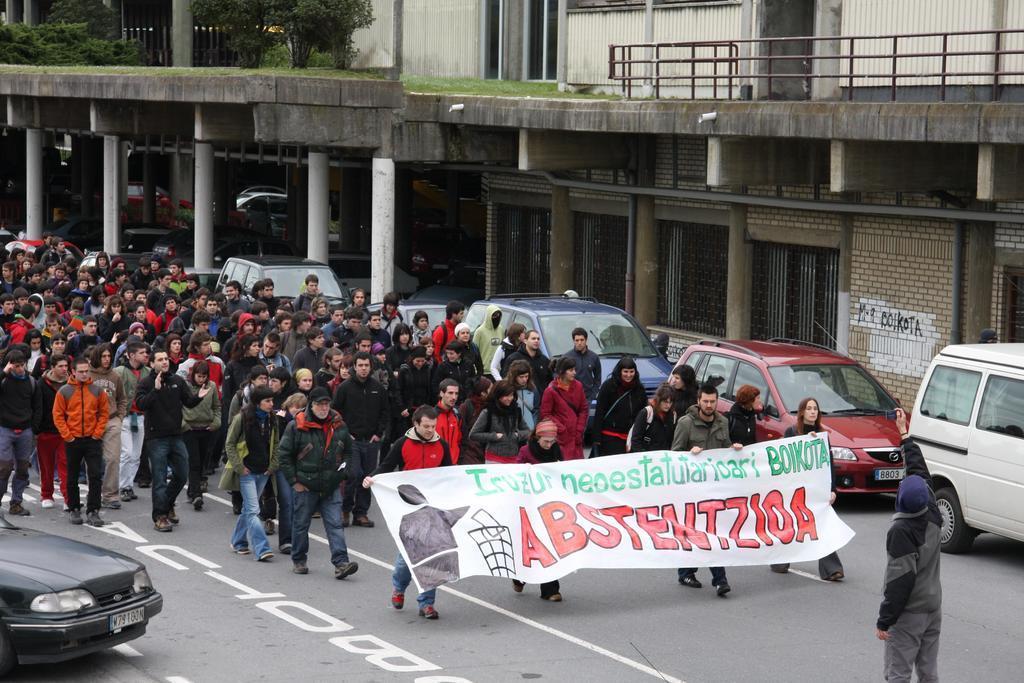How would you summarize this image in a sentence or two? In this image I can see number of persons are standing on the road and I can see few persons are holding a banner which is white, green, red and black in color. I can see few cars on the road, few pillars, few buildings and few trees which are green in color. 